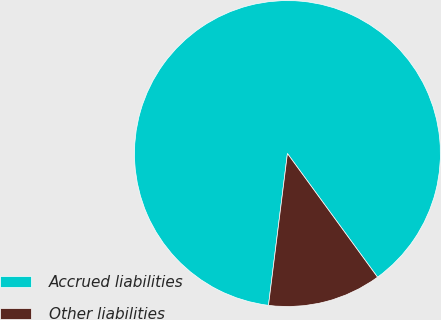<chart> <loc_0><loc_0><loc_500><loc_500><pie_chart><fcel>Accrued liabilities<fcel>Other liabilities<nl><fcel>88.0%<fcel>12.0%<nl></chart> 